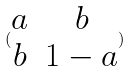Convert formula to latex. <formula><loc_0><loc_0><loc_500><loc_500>( \begin{matrix} a & b \\ b & 1 - a \end{matrix} )</formula> 